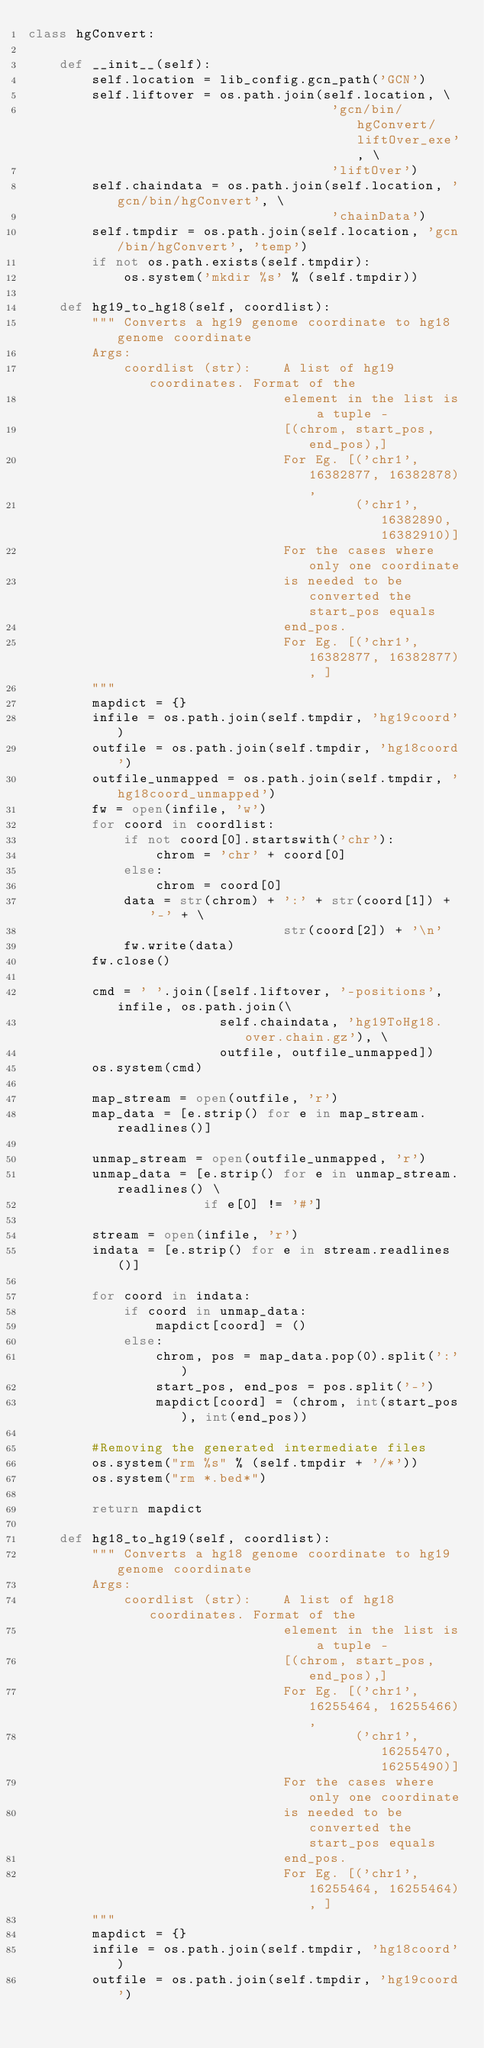<code> <loc_0><loc_0><loc_500><loc_500><_Python_>class hgConvert:

    def __init__(self):
        self.location = lib_config.gcn_path('GCN')
        self.liftover = os.path.join(self.location, \
                                      'gcn/bin/hgConvert/liftOver_exe', \
                                      'liftOver')
        self.chaindata = os.path.join(self.location, 'gcn/bin/hgConvert', \
                                      'chainData')
        self.tmpdir = os.path.join(self.location, 'gcn/bin/hgConvert', 'temp')
        if not os.path.exists(self.tmpdir):
            os.system('mkdir %s' % (self.tmpdir))

    def hg19_to_hg18(self, coordlist):
        """ Converts a hg19 genome coordinate to hg18 genome coordinate
        Args:
            coordlist (str):    A list of hg19 coordinates. Format of the
                                element in the list is a tuple -
                                [(chrom, start_pos, end_pos),]
                                For Eg. [('chr1', 16382877, 16382878),
                                         ('chr1', 16382890, 16382910)]
                                For the cases where only one coordinate
                                is needed to be converted the start_pos equals
                                end_pos.
                                For Eg. [('chr1', 16382877, 16382877), ]
        """
        mapdict = {}
        infile = os.path.join(self.tmpdir, 'hg19coord')
        outfile = os.path.join(self.tmpdir, 'hg18coord')
        outfile_unmapped = os.path.join(self.tmpdir, 'hg18coord_unmapped')
        fw = open(infile, 'w')
        for coord in coordlist:
            if not coord[0].startswith('chr'):
                chrom = 'chr' + coord[0]
            else:
                chrom = coord[0]
            data = str(chrom) + ':' + str(coord[1]) + '-' + \
                                str(coord[2]) + '\n'
            fw.write(data)
        fw.close()

        cmd = ' '.join([self.liftover, '-positions', infile, os.path.join(\
                        self.chaindata, 'hg19ToHg18.over.chain.gz'), \
                        outfile, outfile_unmapped])
        os.system(cmd)

        map_stream = open(outfile, 'r')
        map_data = [e.strip() for e in map_stream.readlines()]

        unmap_stream = open(outfile_unmapped, 'r')
        unmap_data = [e.strip() for e in unmap_stream.readlines() \
                      if e[0] != '#']

        stream = open(infile, 'r')
        indata = [e.strip() for e in stream.readlines()]

        for coord in indata:
            if coord in unmap_data:
                mapdict[coord] = ()
            else:
                chrom, pos = map_data.pop(0).split(':')
                start_pos, end_pos = pos.split('-')
                mapdict[coord] = (chrom, int(start_pos), int(end_pos))

        #Removing the generated intermediate files
        os.system("rm %s" % (self.tmpdir + '/*'))
        os.system("rm *.bed*")

        return mapdict

    def hg18_to_hg19(self, coordlist):
        """ Converts a hg18 genome coordinate to hg19 genome coordinate
        Args:
            coordlist (str):    A list of hg18 coordinates. Format of the
                                element in the list is a tuple -
                                [(chrom, start_pos, end_pos),]
                                For Eg. [('chr1', 16255464, 16255466),
                                         ('chr1', 16255470, 16255490)]
                                For the cases where only one coordinate
                                is needed to be converted the start_pos equals
                                end_pos.
                                For Eg. [('chr1', 16255464, 16255464), ]
        """
        mapdict = {}
        infile = os.path.join(self.tmpdir, 'hg18coord')
        outfile = os.path.join(self.tmpdir, 'hg19coord')</code> 